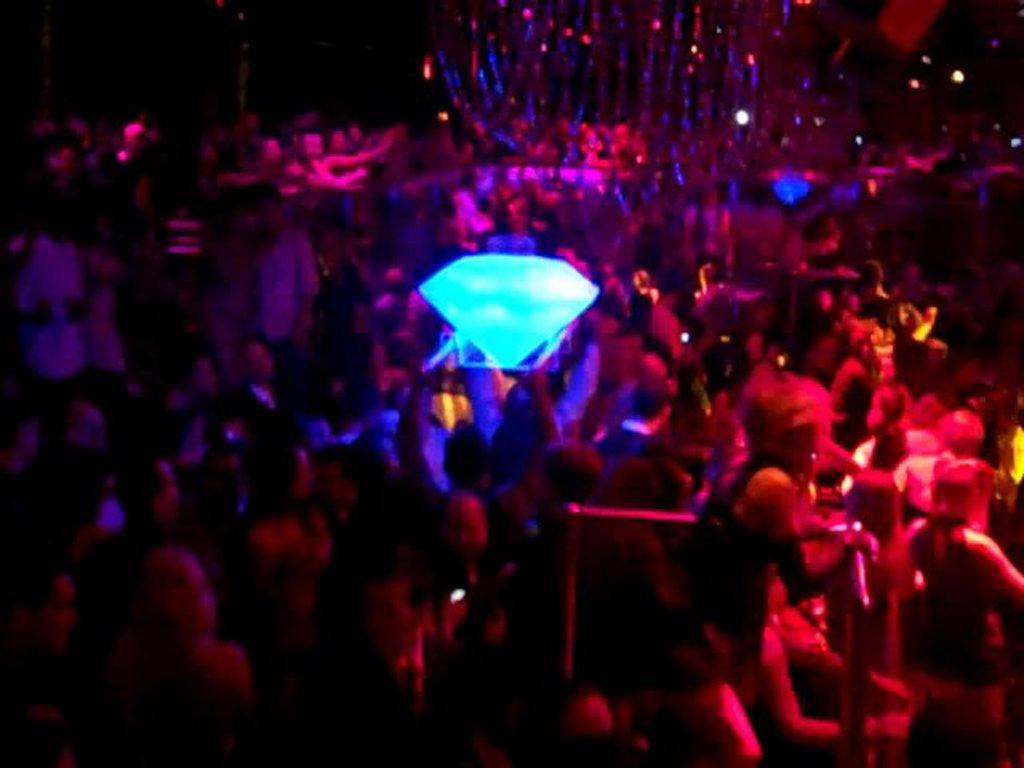How many people are in the image? There is a group of people in the image, but the exact number cannot be determined from the provided facts. What is the shape and color of the object in the image? There is a blue, diamond-shaped object in the image. Can you see a tiger combing its fur in the image? There is no tiger or comb present in the image. What type of rest can be seen in the image? There is no rest or resting object present in the image. 